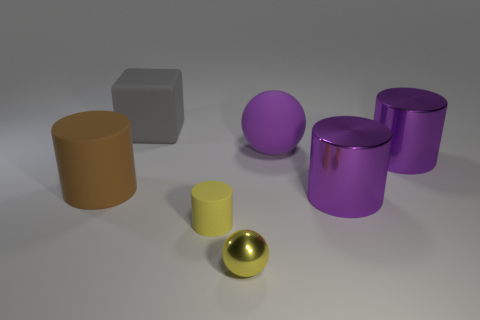Add 3 large objects. How many objects exist? 10 Subtract all large matte cylinders. How many cylinders are left? 3 Subtract all yellow spheres. How many spheres are left? 1 Subtract all cubes. How many objects are left? 6 Subtract 1 balls. How many balls are left? 1 Subtract all cyan cylinders. How many purple balls are left? 1 Add 3 tiny cubes. How many tiny cubes exist? 3 Subtract 0 green cubes. How many objects are left? 7 Subtract all gray cylinders. Subtract all brown spheres. How many cylinders are left? 4 Subtract all big purple rubber spheres. Subtract all red rubber cubes. How many objects are left? 6 